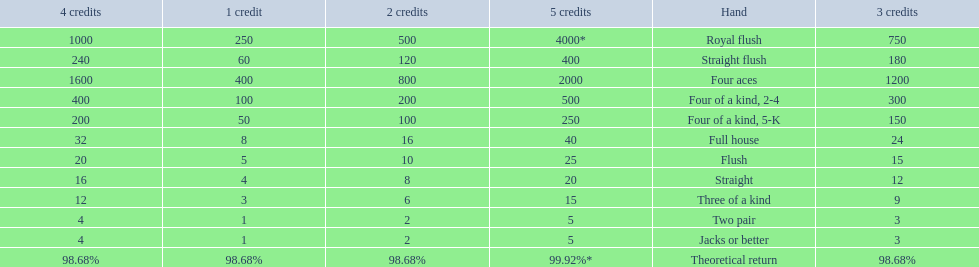What is the higher amount of points for one credit you can get from the best four of a kind 100. What type is it? Four of a kind, 2-4. 